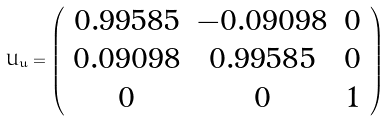Convert formula to latex. <formula><loc_0><loc_0><loc_500><loc_500>U _ { u } = \left ( \begin{array} { c c c } 0 . 9 9 5 8 5 & - 0 . 0 9 0 9 8 & 0 \\ 0 . 0 9 0 9 8 & 0 . 9 9 5 8 5 & 0 \\ 0 & 0 & 1 \end{array} \right )</formula> 